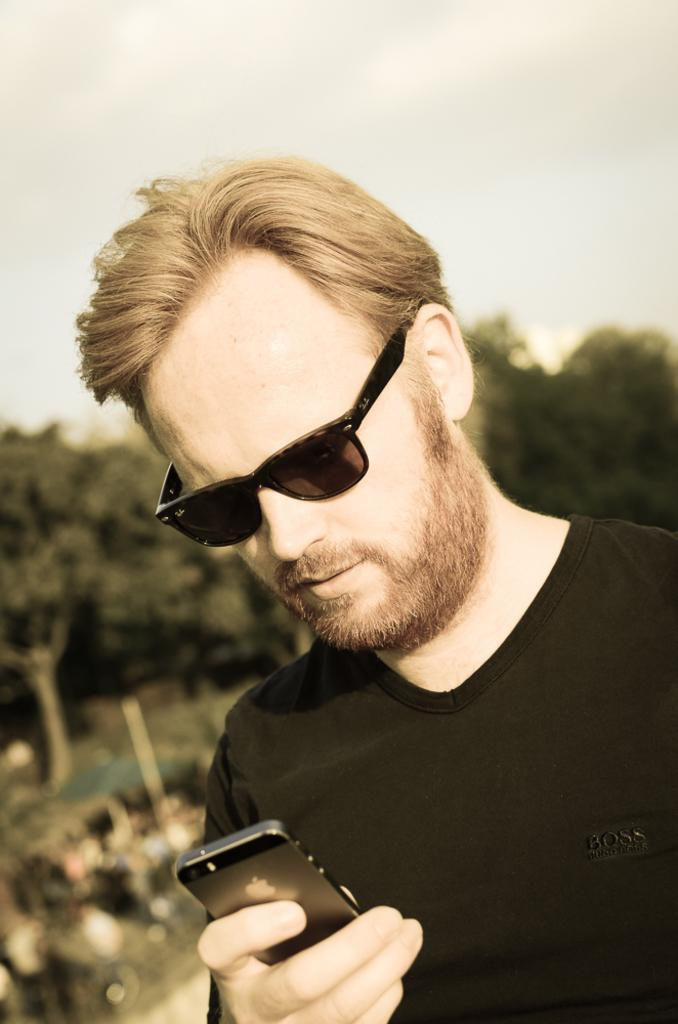What can be seen in the image? There is a person in the image, along with objects, trees, and the sky. Can you describe the person in the image? The person is wearing spectacles and holding a mobile phone. What type of objects are visible in the image? The specific objects are not mentioned, but we know there are objects present. What can be seen in the background of the image? Trees and the sky are visible in the background of the image. How many ducks are sitting on the person's head in the image? There are no ducks present in the image, so it is not possible to answer that question. 